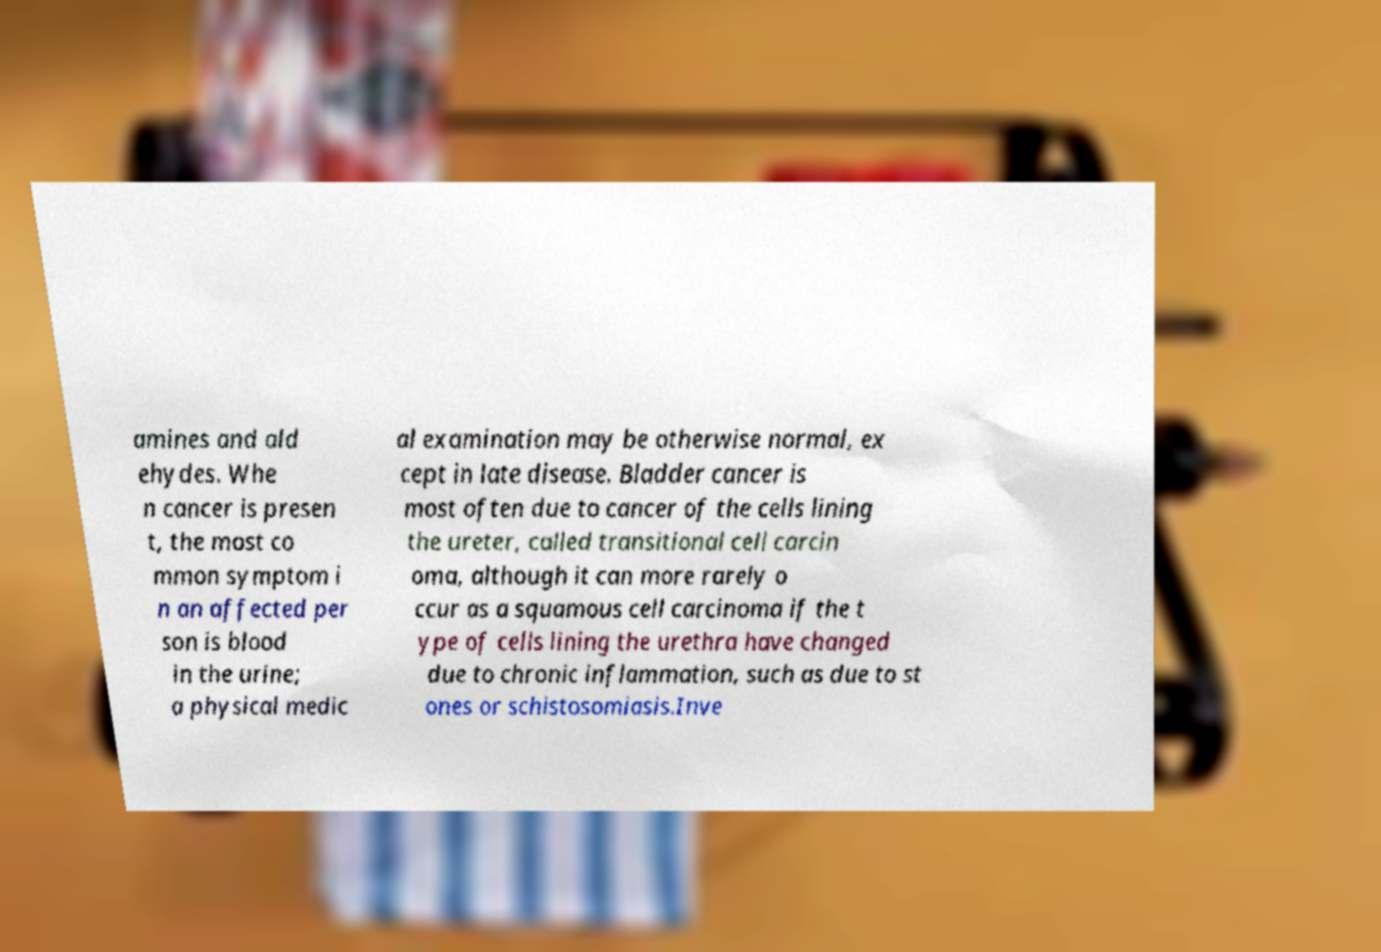Could you extract and type out the text from this image? amines and ald ehydes. Whe n cancer is presen t, the most co mmon symptom i n an affected per son is blood in the urine; a physical medic al examination may be otherwise normal, ex cept in late disease. Bladder cancer is most often due to cancer of the cells lining the ureter, called transitional cell carcin oma, although it can more rarely o ccur as a squamous cell carcinoma if the t ype of cells lining the urethra have changed due to chronic inflammation, such as due to st ones or schistosomiasis.Inve 